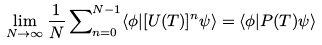Convert formula to latex. <formula><loc_0><loc_0><loc_500><loc_500>\lim _ { N \rightarrow \infty } \frac { 1 } { N } \sum \nolimits _ { n = 0 } ^ { N - 1 } \langle \phi | [ U ( T ) ] ^ { n } \psi \rangle = \langle \phi | P ( T ) \psi \rangle</formula> 